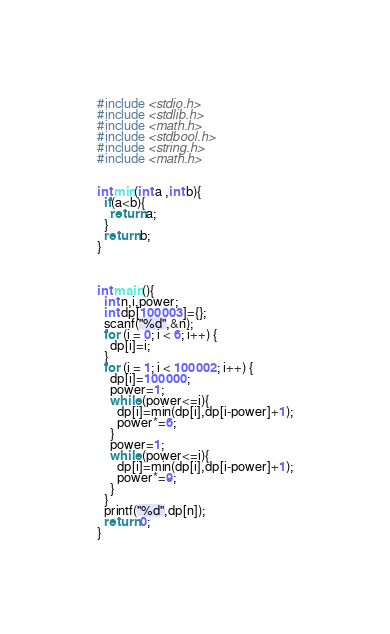Convert code to text. <code><loc_0><loc_0><loc_500><loc_500><_C_>#include <stdio.h>
#include <stdlib.h>
#include <math.h>
#include <stdbool.h>
#include <string.h>
#include <math.h>


int min(int a ,int b){
  if(a<b){
    return a;
  }
  return b;
}



int main(){
  int n,i,power;
  int dp[100003]={};
  scanf("%d",&n);
  for (i = 0; i < 6; i++) {
    dp[i]=i;
  }
  for (i = 1; i < 100002; i++) {
    dp[i]=100000;
    power=1;
    while (power<=i){
      dp[i]=min(dp[i],dp[i-power]+1);
      power*=6;
    }
    power=1;
    while (power<=i){
      dp[i]=min(dp[i],dp[i-power]+1);
      power*=9;
    }
  }
  printf("%d",dp[n]);
  return 0;
}
</code> 